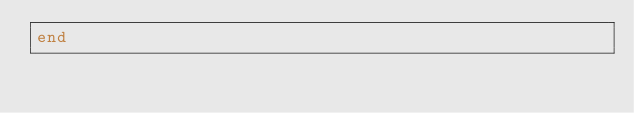Convert code to text. <code><loc_0><loc_0><loc_500><loc_500><_Ruby_>end
</code> 